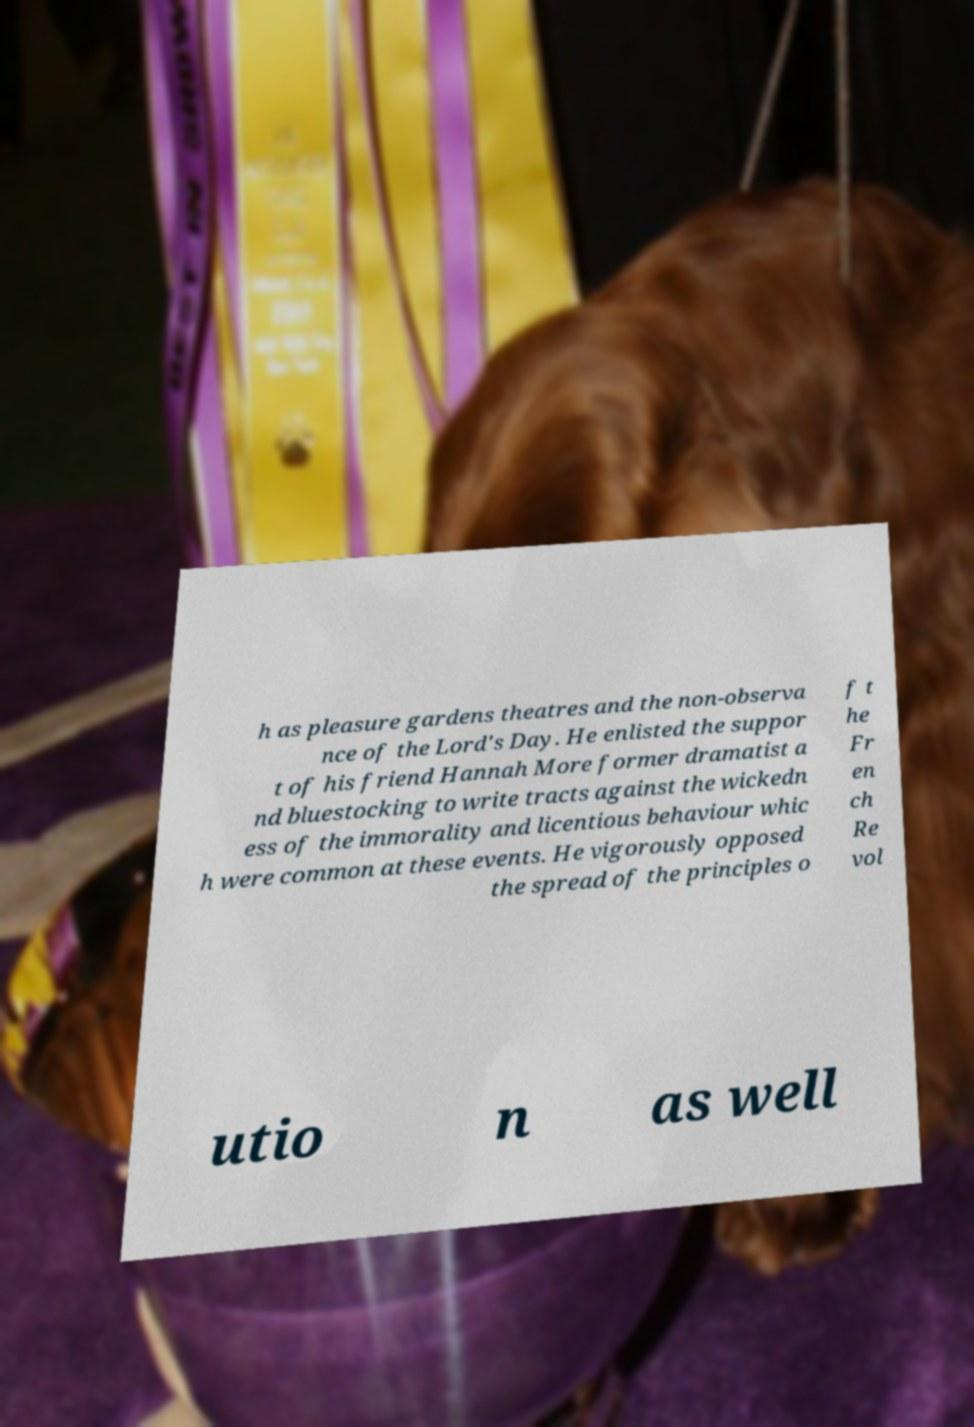For documentation purposes, I need the text within this image transcribed. Could you provide that? h as pleasure gardens theatres and the non-observa nce of the Lord's Day. He enlisted the suppor t of his friend Hannah More former dramatist a nd bluestocking to write tracts against the wickedn ess of the immorality and licentious behaviour whic h were common at these events. He vigorously opposed the spread of the principles o f t he Fr en ch Re vol utio n as well 